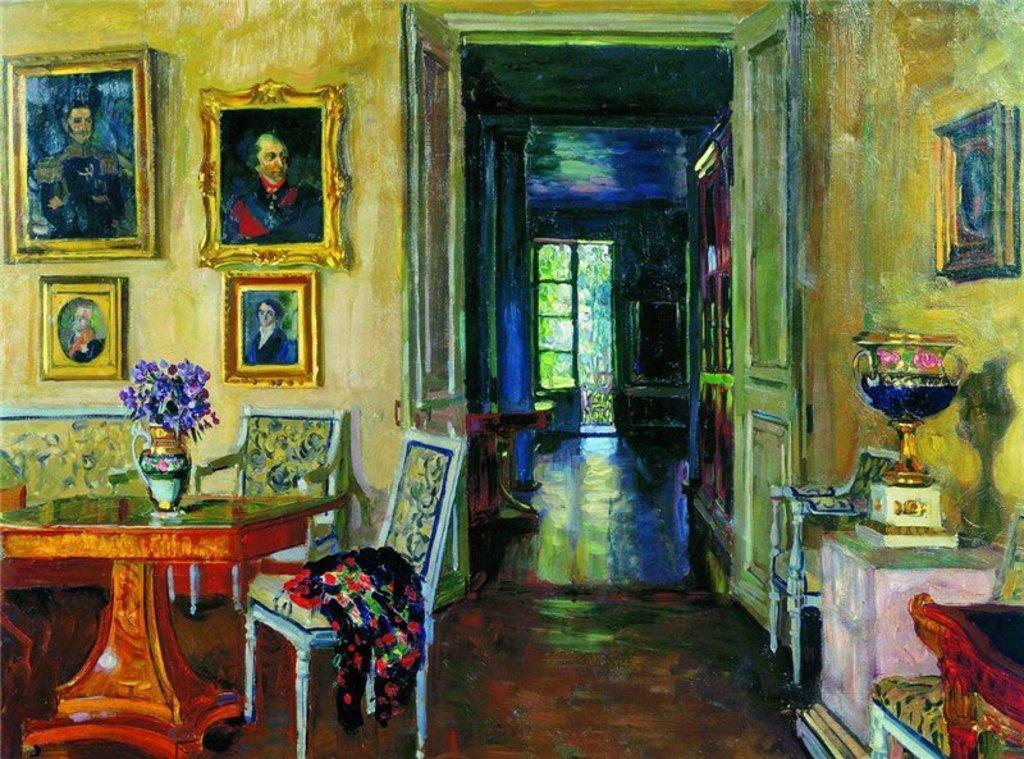Please provide a concise description of this image. It is a painting image. On the left side of the image there is a table. On top of it there is a flower pot. There are chairs. In the background of the image there are photo frames on the wall. On the left side of the image there is a table. There are chairs. There is a pillar. On top of it there is a cup. At the bottom of the image there is a floor. In the center of the image there is a door. There is a glass window through which we can see trees. 